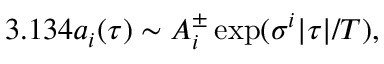<formula> <loc_0><loc_0><loc_500><loc_500>3 . 1 3 4 { a _ { i } } ( \tau ) \sim A _ { i } ^ { \pm } \exp ( \sigma ^ { i } | \tau | / T ) ,</formula> 